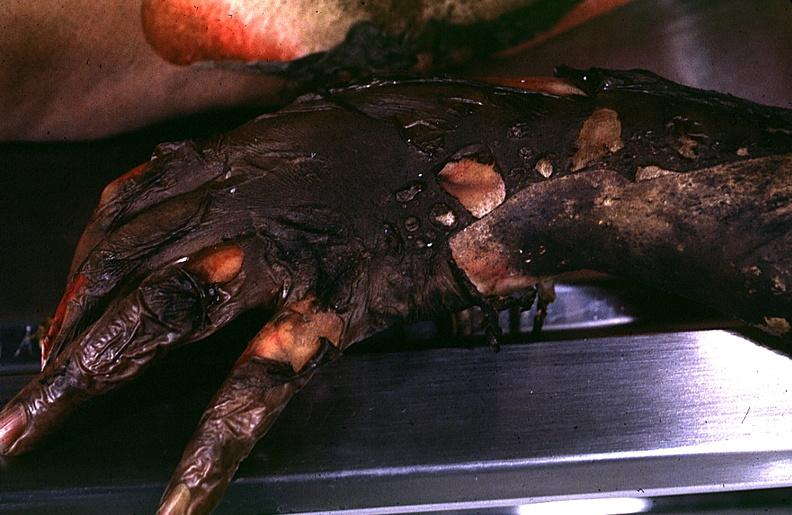where is this?
Answer the question using a single word or phrase. Skin 